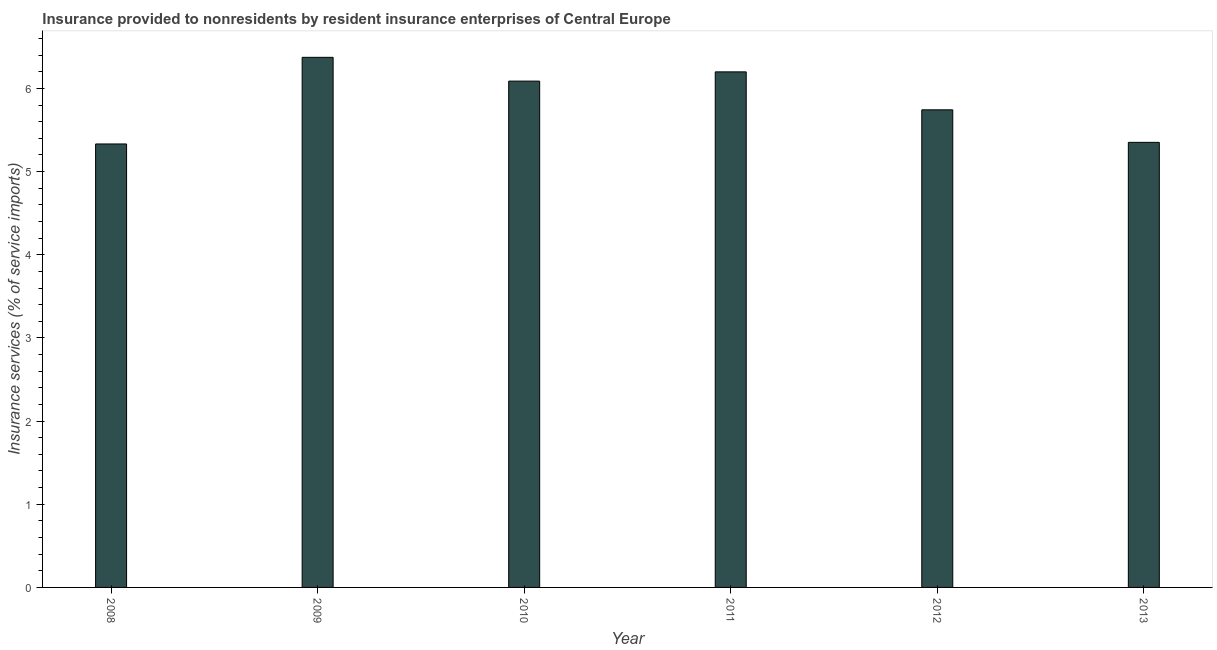Does the graph contain any zero values?
Your response must be concise. No. Does the graph contain grids?
Provide a short and direct response. No. What is the title of the graph?
Make the answer very short. Insurance provided to nonresidents by resident insurance enterprises of Central Europe. What is the label or title of the X-axis?
Your response must be concise. Year. What is the label or title of the Y-axis?
Your answer should be very brief. Insurance services (% of service imports). What is the insurance and financial services in 2009?
Your answer should be compact. 6.37. Across all years, what is the maximum insurance and financial services?
Provide a succinct answer. 6.37. Across all years, what is the minimum insurance and financial services?
Make the answer very short. 5.33. In which year was the insurance and financial services minimum?
Your response must be concise. 2008. What is the sum of the insurance and financial services?
Provide a short and direct response. 35.09. What is the difference between the insurance and financial services in 2010 and 2011?
Your answer should be compact. -0.11. What is the average insurance and financial services per year?
Your answer should be very brief. 5.85. What is the median insurance and financial services?
Give a very brief answer. 5.92. What is the ratio of the insurance and financial services in 2008 to that in 2012?
Offer a very short reply. 0.93. Is the insurance and financial services in 2009 less than that in 2010?
Offer a very short reply. No. Is the difference between the insurance and financial services in 2009 and 2013 greater than the difference between any two years?
Provide a short and direct response. No. What is the difference between the highest and the second highest insurance and financial services?
Offer a terse response. 0.17. Is the sum of the insurance and financial services in 2008 and 2010 greater than the maximum insurance and financial services across all years?
Your answer should be very brief. Yes. What is the difference between the highest and the lowest insurance and financial services?
Give a very brief answer. 1.04. How many bars are there?
Provide a short and direct response. 6. How many years are there in the graph?
Your answer should be very brief. 6. What is the Insurance services (% of service imports) in 2008?
Offer a very short reply. 5.33. What is the Insurance services (% of service imports) of 2009?
Ensure brevity in your answer.  6.37. What is the Insurance services (% of service imports) in 2010?
Provide a short and direct response. 6.09. What is the Insurance services (% of service imports) in 2011?
Offer a terse response. 6.2. What is the Insurance services (% of service imports) in 2012?
Make the answer very short. 5.74. What is the Insurance services (% of service imports) in 2013?
Offer a very short reply. 5.35. What is the difference between the Insurance services (% of service imports) in 2008 and 2009?
Your answer should be compact. -1.04. What is the difference between the Insurance services (% of service imports) in 2008 and 2010?
Keep it short and to the point. -0.76. What is the difference between the Insurance services (% of service imports) in 2008 and 2011?
Your answer should be compact. -0.87. What is the difference between the Insurance services (% of service imports) in 2008 and 2012?
Provide a succinct answer. -0.41. What is the difference between the Insurance services (% of service imports) in 2008 and 2013?
Offer a terse response. -0.02. What is the difference between the Insurance services (% of service imports) in 2009 and 2010?
Your answer should be compact. 0.29. What is the difference between the Insurance services (% of service imports) in 2009 and 2011?
Keep it short and to the point. 0.17. What is the difference between the Insurance services (% of service imports) in 2009 and 2012?
Provide a succinct answer. 0.63. What is the difference between the Insurance services (% of service imports) in 2009 and 2013?
Offer a very short reply. 1.02. What is the difference between the Insurance services (% of service imports) in 2010 and 2011?
Ensure brevity in your answer.  -0.11. What is the difference between the Insurance services (% of service imports) in 2010 and 2012?
Ensure brevity in your answer.  0.35. What is the difference between the Insurance services (% of service imports) in 2010 and 2013?
Keep it short and to the point. 0.74. What is the difference between the Insurance services (% of service imports) in 2011 and 2012?
Your response must be concise. 0.46. What is the difference between the Insurance services (% of service imports) in 2011 and 2013?
Provide a short and direct response. 0.85. What is the difference between the Insurance services (% of service imports) in 2012 and 2013?
Offer a terse response. 0.39. What is the ratio of the Insurance services (% of service imports) in 2008 to that in 2009?
Provide a short and direct response. 0.84. What is the ratio of the Insurance services (% of service imports) in 2008 to that in 2010?
Provide a succinct answer. 0.88. What is the ratio of the Insurance services (% of service imports) in 2008 to that in 2011?
Offer a very short reply. 0.86. What is the ratio of the Insurance services (% of service imports) in 2008 to that in 2012?
Provide a short and direct response. 0.93. What is the ratio of the Insurance services (% of service imports) in 2008 to that in 2013?
Offer a very short reply. 1. What is the ratio of the Insurance services (% of service imports) in 2009 to that in 2010?
Ensure brevity in your answer.  1.05. What is the ratio of the Insurance services (% of service imports) in 2009 to that in 2011?
Your answer should be very brief. 1.03. What is the ratio of the Insurance services (% of service imports) in 2009 to that in 2012?
Keep it short and to the point. 1.11. What is the ratio of the Insurance services (% of service imports) in 2009 to that in 2013?
Provide a succinct answer. 1.19. What is the ratio of the Insurance services (% of service imports) in 2010 to that in 2012?
Offer a terse response. 1.06. What is the ratio of the Insurance services (% of service imports) in 2010 to that in 2013?
Ensure brevity in your answer.  1.14. What is the ratio of the Insurance services (% of service imports) in 2011 to that in 2012?
Your answer should be compact. 1.08. What is the ratio of the Insurance services (% of service imports) in 2011 to that in 2013?
Make the answer very short. 1.16. What is the ratio of the Insurance services (% of service imports) in 2012 to that in 2013?
Your response must be concise. 1.07. 